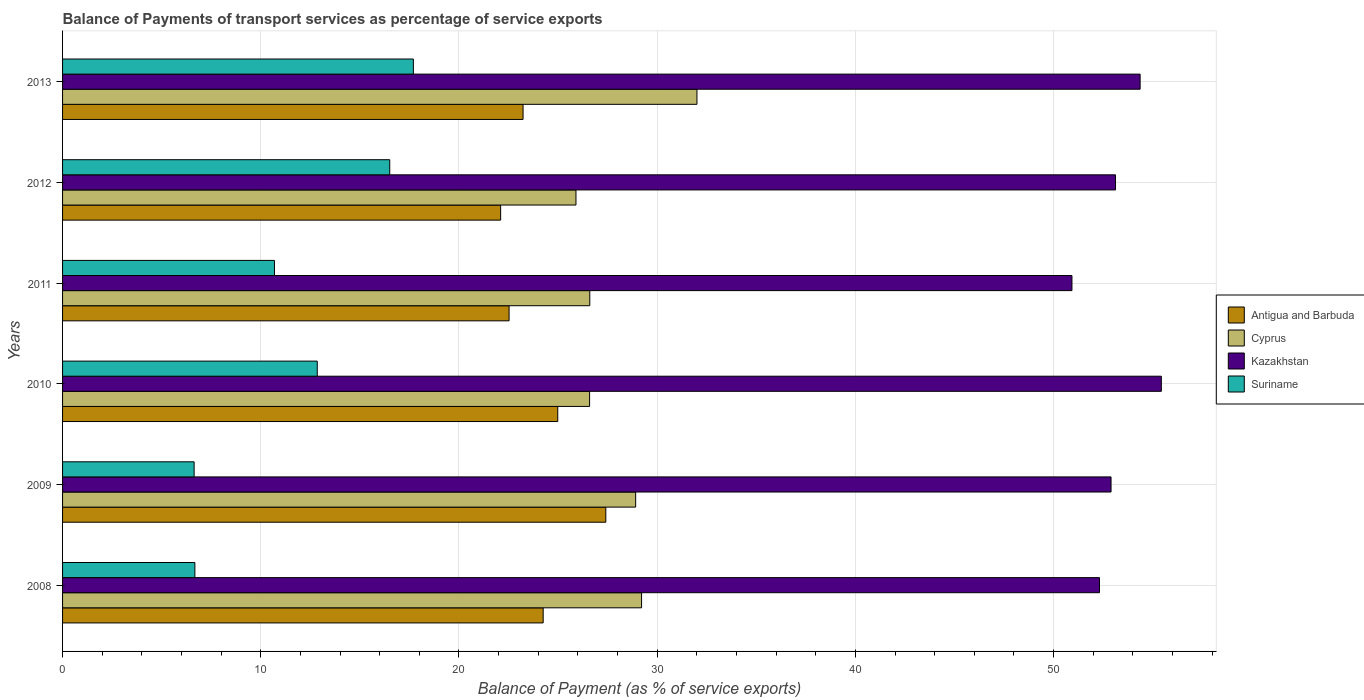How many groups of bars are there?
Your answer should be very brief. 6. Are the number of bars per tick equal to the number of legend labels?
Offer a very short reply. Yes. What is the label of the 1st group of bars from the top?
Provide a succinct answer. 2013. What is the balance of payments of transport services in Antigua and Barbuda in 2009?
Keep it short and to the point. 27.41. Across all years, what is the maximum balance of payments of transport services in Cyprus?
Give a very brief answer. 32.01. Across all years, what is the minimum balance of payments of transport services in Cyprus?
Keep it short and to the point. 25.9. In which year was the balance of payments of transport services in Kazakhstan minimum?
Ensure brevity in your answer.  2011. What is the total balance of payments of transport services in Kazakhstan in the graph?
Your answer should be compact. 319.06. What is the difference between the balance of payments of transport services in Cyprus in 2008 and that in 2010?
Provide a short and direct response. 2.62. What is the difference between the balance of payments of transport services in Suriname in 2010 and the balance of payments of transport services in Cyprus in 2013?
Offer a terse response. -19.16. What is the average balance of payments of transport services in Suriname per year?
Offer a very short reply. 11.84. In the year 2012, what is the difference between the balance of payments of transport services in Antigua and Barbuda and balance of payments of transport services in Suriname?
Your answer should be compact. 5.6. What is the ratio of the balance of payments of transport services in Antigua and Barbuda in 2010 to that in 2013?
Your response must be concise. 1.08. Is the balance of payments of transport services in Suriname in 2010 less than that in 2011?
Ensure brevity in your answer.  No. Is the difference between the balance of payments of transport services in Antigua and Barbuda in 2008 and 2011 greater than the difference between the balance of payments of transport services in Suriname in 2008 and 2011?
Provide a succinct answer. Yes. What is the difference between the highest and the second highest balance of payments of transport services in Antigua and Barbuda?
Provide a succinct answer. 2.43. What is the difference between the highest and the lowest balance of payments of transport services in Antigua and Barbuda?
Provide a short and direct response. 5.31. In how many years, is the balance of payments of transport services in Suriname greater than the average balance of payments of transport services in Suriname taken over all years?
Ensure brevity in your answer.  3. Is the sum of the balance of payments of transport services in Cyprus in 2008 and 2009 greater than the maximum balance of payments of transport services in Suriname across all years?
Provide a succinct answer. Yes. Is it the case that in every year, the sum of the balance of payments of transport services in Suriname and balance of payments of transport services in Kazakhstan is greater than the sum of balance of payments of transport services in Antigua and Barbuda and balance of payments of transport services in Cyprus?
Ensure brevity in your answer.  Yes. What does the 2nd bar from the top in 2011 represents?
Provide a short and direct response. Kazakhstan. What does the 2nd bar from the bottom in 2009 represents?
Your response must be concise. Cyprus. How many bars are there?
Provide a succinct answer. 24. Are all the bars in the graph horizontal?
Provide a short and direct response. Yes. How many years are there in the graph?
Your answer should be compact. 6. What is the difference between two consecutive major ticks on the X-axis?
Provide a succinct answer. 10. Are the values on the major ticks of X-axis written in scientific E-notation?
Your answer should be very brief. No. How many legend labels are there?
Provide a short and direct response. 4. What is the title of the graph?
Provide a short and direct response. Balance of Payments of transport services as percentage of service exports. Does "Congo (Republic)" appear as one of the legend labels in the graph?
Offer a terse response. No. What is the label or title of the X-axis?
Give a very brief answer. Balance of Payment (as % of service exports). What is the Balance of Payment (as % of service exports) of Antigua and Barbuda in 2008?
Your answer should be compact. 24.25. What is the Balance of Payment (as % of service exports) in Cyprus in 2008?
Provide a succinct answer. 29.21. What is the Balance of Payment (as % of service exports) in Kazakhstan in 2008?
Your answer should be compact. 52.32. What is the Balance of Payment (as % of service exports) of Suriname in 2008?
Provide a short and direct response. 6.67. What is the Balance of Payment (as % of service exports) in Antigua and Barbuda in 2009?
Your answer should be very brief. 27.41. What is the Balance of Payment (as % of service exports) of Cyprus in 2009?
Give a very brief answer. 28.91. What is the Balance of Payment (as % of service exports) in Kazakhstan in 2009?
Offer a terse response. 52.9. What is the Balance of Payment (as % of service exports) in Suriname in 2009?
Ensure brevity in your answer.  6.64. What is the Balance of Payment (as % of service exports) of Antigua and Barbuda in 2010?
Offer a terse response. 24.98. What is the Balance of Payment (as % of service exports) of Cyprus in 2010?
Offer a very short reply. 26.59. What is the Balance of Payment (as % of service exports) of Kazakhstan in 2010?
Offer a terse response. 55.44. What is the Balance of Payment (as % of service exports) of Suriname in 2010?
Your answer should be very brief. 12.85. What is the Balance of Payment (as % of service exports) of Antigua and Barbuda in 2011?
Your answer should be compact. 22.53. What is the Balance of Payment (as % of service exports) of Cyprus in 2011?
Offer a very short reply. 26.6. What is the Balance of Payment (as % of service exports) in Kazakhstan in 2011?
Give a very brief answer. 50.93. What is the Balance of Payment (as % of service exports) of Suriname in 2011?
Provide a short and direct response. 10.69. What is the Balance of Payment (as % of service exports) of Antigua and Barbuda in 2012?
Your answer should be very brief. 22.1. What is the Balance of Payment (as % of service exports) of Cyprus in 2012?
Your answer should be compact. 25.9. What is the Balance of Payment (as % of service exports) of Kazakhstan in 2012?
Keep it short and to the point. 53.12. What is the Balance of Payment (as % of service exports) of Suriname in 2012?
Keep it short and to the point. 16.51. What is the Balance of Payment (as % of service exports) in Antigua and Barbuda in 2013?
Make the answer very short. 23.23. What is the Balance of Payment (as % of service exports) in Cyprus in 2013?
Make the answer very short. 32.01. What is the Balance of Payment (as % of service exports) in Kazakhstan in 2013?
Your answer should be very brief. 54.36. What is the Balance of Payment (as % of service exports) of Suriname in 2013?
Keep it short and to the point. 17.7. Across all years, what is the maximum Balance of Payment (as % of service exports) of Antigua and Barbuda?
Your response must be concise. 27.41. Across all years, what is the maximum Balance of Payment (as % of service exports) in Cyprus?
Give a very brief answer. 32.01. Across all years, what is the maximum Balance of Payment (as % of service exports) in Kazakhstan?
Keep it short and to the point. 55.44. Across all years, what is the maximum Balance of Payment (as % of service exports) of Suriname?
Offer a very short reply. 17.7. Across all years, what is the minimum Balance of Payment (as % of service exports) of Antigua and Barbuda?
Provide a succinct answer. 22.1. Across all years, what is the minimum Balance of Payment (as % of service exports) of Cyprus?
Keep it short and to the point. 25.9. Across all years, what is the minimum Balance of Payment (as % of service exports) of Kazakhstan?
Offer a terse response. 50.93. Across all years, what is the minimum Balance of Payment (as % of service exports) of Suriname?
Provide a succinct answer. 6.64. What is the total Balance of Payment (as % of service exports) in Antigua and Barbuda in the graph?
Make the answer very short. 144.5. What is the total Balance of Payment (as % of service exports) of Cyprus in the graph?
Give a very brief answer. 169.22. What is the total Balance of Payment (as % of service exports) of Kazakhstan in the graph?
Make the answer very short. 319.06. What is the total Balance of Payment (as % of service exports) in Suriname in the graph?
Keep it short and to the point. 71.06. What is the difference between the Balance of Payment (as % of service exports) of Antigua and Barbuda in 2008 and that in 2009?
Your answer should be very brief. -3.16. What is the difference between the Balance of Payment (as % of service exports) of Cyprus in 2008 and that in 2009?
Keep it short and to the point. 0.3. What is the difference between the Balance of Payment (as % of service exports) in Kazakhstan in 2008 and that in 2009?
Provide a succinct answer. -0.58. What is the difference between the Balance of Payment (as % of service exports) of Suriname in 2008 and that in 2009?
Your answer should be very brief. 0.04. What is the difference between the Balance of Payment (as % of service exports) in Antigua and Barbuda in 2008 and that in 2010?
Give a very brief answer. -0.74. What is the difference between the Balance of Payment (as % of service exports) in Cyprus in 2008 and that in 2010?
Ensure brevity in your answer.  2.62. What is the difference between the Balance of Payment (as % of service exports) in Kazakhstan in 2008 and that in 2010?
Give a very brief answer. -3.12. What is the difference between the Balance of Payment (as % of service exports) in Suriname in 2008 and that in 2010?
Provide a short and direct response. -6.18. What is the difference between the Balance of Payment (as % of service exports) in Antigua and Barbuda in 2008 and that in 2011?
Give a very brief answer. 1.72. What is the difference between the Balance of Payment (as % of service exports) of Cyprus in 2008 and that in 2011?
Your response must be concise. 2.61. What is the difference between the Balance of Payment (as % of service exports) of Kazakhstan in 2008 and that in 2011?
Make the answer very short. 1.39. What is the difference between the Balance of Payment (as % of service exports) in Suriname in 2008 and that in 2011?
Your answer should be very brief. -4.02. What is the difference between the Balance of Payment (as % of service exports) in Antigua and Barbuda in 2008 and that in 2012?
Your answer should be very brief. 2.15. What is the difference between the Balance of Payment (as % of service exports) of Cyprus in 2008 and that in 2012?
Offer a very short reply. 3.31. What is the difference between the Balance of Payment (as % of service exports) of Kazakhstan in 2008 and that in 2012?
Provide a succinct answer. -0.81. What is the difference between the Balance of Payment (as % of service exports) in Suriname in 2008 and that in 2012?
Your response must be concise. -9.83. What is the difference between the Balance of Payment (as % of service exports) of Antigua and Barbuda in 2008 and that in 2013?
Keep it short and to the point. 1.01. What is the difference between the Balance of Payment (as % of service exports) of Cyprus in 2008 and that in 2013?
Your response must be concise. -2.79. What is the difference between the Balance of Payment (as % of service exports) of Kazakhstan in 2008 and that in 2013?
Keep it short and to the point. -2.05. What is the difference between the Balance of Payment (as % of service exports) in Suriname in 2008 and that in 2013?
Keep it short and to the point. -11.02. What is the difference between the Balance of Payment (as % of service exports) of Antigua and Barbuda in 2009 and that in 2010?
Your answer should be very brief. 2.43. What is the difference between the Balance of Payment (as % of service exports) of Cyprus in 2009 and that in 2010?
Your answer should be compact. 2.32. What is the difference between the Balance of Payment (as % of service exports) of Kazakhstan in 2009 and that in 2010?
Make the answer very short. -2.54. What is the difference between the Balance of Payment (as % of service exports) of Suriname in 2009 and that in 2010?
Provide a short and direct response. -6.21. What is the difference between the Balance of Payment (as % of service exports) of Antigua and Barbuda in 2009 and that in 2011?
Provide a succinct answer. 4.88. What is the difference between the Balance of Payment (as % of service exports) of Cyprus in 2009 and that in 2011?
Offer a terse response. 2.31. What is the difference between the Balance of Payment (as % of service exports) of Kazakhstan in 2009 and that in 2011?
Your response must be concise. 1.97. What is the difference between the Balance of Payment (as % of service exports) in Suriname in 2009 and that in 2011?
Your response must be concise. -4.05. What is the difference between the Balance of Payment (as % of service exports) of Antigua and Barbuda in 2009 and that in 2012?
Offer a terse response. 5.31. What is the difference between the Balance of Payment (as % of service exports) of Cyprus in 2009 and that in 2012?
Offer a very short reply. 3.01. What is the difference between the Balance of Payment (as % of service exports) in Kazakhstan in 2009 and that in 2012?
Provide a succinct answer. -0.23. What is the difference between the Balance of Payment (as % of service exports) of Suriname in 2009 and that in 2012?
Ensure brevity in your answer.  -9.87. What is the difference between the Balance of Payment (as % of service exports) in Antigua and Barbuda in 2009 and that in 2013?
Your answer should be very brief. 4.17. What is the difference between the Balance of Payment (as % of service exports) in Cyprus in 2009 and that in 2013?
Provide a succinct answer. -3.09. What is the difference between the Balance of Payment (as % of service exports) of Kazakhstan in 2009 and that in 2013?
Offer a very short reply. -1.47. What is the difference between the Balance of Payment (as % of service exports) in Suriname in 2009 and that in 2013?
Ensure brevity in your answer.  -11.06. What is the difference between the Balance of Payment (as % of service exports) of Antigua and Barbuda in 2010 and that in 2011?
Your answer should be compact. 2.46. What is the difference between the Balance of Payment (as % of service exports) in Cyprus in 2010 and that in 2011?
Your response must be concise. -0.01. What is the difference between the Balance of Payment (as % of service exports) of Kazakhstan in 2010 and that in 2011?
Provide a short and direct response. 4.51. What is the difference between the Balance of Payment (as % of service exports) in Suriname in 2010 and that in 2011?
Offer a very short reply. 2.16. What is the difference between the Balance of Payment (as % of service exports) in Antigua and Barbuda in 2010 and that in 2012?
Your answer should be compact. 2.88. What is the difference between the Balance of Payment (as % of service exports) of Cyprus in 2010 and that in 2012?
Your response must be concise. 0.69. What is the difference between the Balance of Payment (as % of service exports) of Kazakhstan in 2010 and that in 2012?
Provide a succinct answer. 2.31. What is the difference between the Balance of Payment (as % of service exports) in Suriname in 2010 and that in 2012?
Give a very brief answer. -3.66. What is the difference between the Balance of Payment (as % of service exports) of Antigua and Barbuda in 2010 and that in 2013?
Your answer should be very brief. 1.75. What is the difference between the Balance of Payment (as % of service exports) in Cyprus in 2010 and that in 2013?
Your answer should be compact. -5.42. What is the difference between the Balance of Payment (as % of service exports) of Kazakhstan in 2010 and that in 2013?
Your response must be concise. 1.07. What is the difference between the Balance of Payment (as % of service exports) in Suriname in 2010 and that in 2013?
Your response must be concise. -4.85. What is the difference between the Balance of Payment (as % of service exports) of Antigua and Barbuda in 2011 and that in 2012?
Make the answer very short. 0.43. What is the difference between the Balance of Payment (as % of service exports) of Cyprus in 2011 and that in 2012?
Give a very brief answer. 0.7. What is the difference between the Balance of Payment (as % of service exports) of Kazakhstan in 2011 and that in 2012?
Ensure brevity in your answer.  -2.2. What is the difference between the Balance of Payment (as % of service exports) in Suriname in 2011 and that in 2012?
Keep it short and to the point. -5.82. What is the difference between the Balance of Payment (as % of service exports) of Antigua and Barbuda in 2011 and that in 2013?
Provide a short and direct response. -0.71. What is the difference between the Balance of Payment (as % of service exports) of Cyprus in 2011 and that in 2013?
Provide a succinct answer. -5.41. What is the difference between the Balance of Payment (as % of service exports) of Kazakhstan in 2011 and that in 2013?
Your answer should be compact. -3.44. What is the difference between the Balance of Payment (as % of service exports) of Suriname in 2011 and that in 2013?
Provide a succinct answer. -7.01. What is the difference between the Balance of Payment (as % of service exports) of Antigua and Barbuda in 2012 and that in 2013?
Make the answer very short. -1.13. What is the difference between the Balance of Payment (as % of service exports) in Cyprus in 2012 and that in 2013?
Provide a short and direct response. -6.1. What is the difference between the Balance of Payment (as % of service exports) in Kazakhstan in 2012 and that in 2013?
Your response must be concise. -1.24. What is the difference between the Balance of Payment (as % of service exports) in Suriname in 2012 and that in 2013?
Offer a terse response. -1.19. What is the difference between the Balance of Payment (as % of service exports) of Antigua and Barbuda in 2008 and the Balance of Payment (as % of service exports) of Cyprus in 2009?
Your answer should be compact. -4.67. What is the difference between the Balance of Payment (as % of service exports) in Antigua and Barbuda in 2008 and the Balance of Payment (as % of service exports) in Kazakhstan in 2009?
Your answer should be compact. -28.65. What is the difference between the Balance of Payment (as % of service exports) of Antigua and Barbuda in 2008 and the Balance of Payment (as % of service exports) of Suriname in 2009?
Your response must be concise. 17.61. What is the difference between the Balance of Payment (as % of service exports) in Cyprus in 2008 and the Balance of Payment (as % of service exports) in Kazakhstan in 2009?
Offer a terse response. -23.69. What is the difference between the Balance of Payment (as % of service exports) of Cyprus in 2008 and the Balance of Payment (as % of service exports) of Suriname in 2009?
Your answer should be compact. 22.57. What is the difference between the Balance of Payment (as % of service exports) of Kazakhstan in 2008 and the Balance of Payment (as % of service exports) of Suriname in 2009?
Provide a succinct answer. 45.68. What is the difference between the Balance of Payment (as % of service exports) of Antigua and Barbuda in 2008 and the Balance of Payment (as % of service exports) of Cyprus in 2010?
Provide a short and direct response. -2.34. What is the difference between the Balance of Payment (as % of service exports) in Antigua and Barbuda in 2008 and the Balance of Payment (as % of service exports) in Kazakhstan in 2010?
Give a very brief answer. -31.19. What is the difference between the Balance of Payment (as % of service exports) of Antigua and Barbuda in 2008 and the Balance of Payment (as % of service exports) of Suriname in 2010?
Keep it short and to the point. 11.4. What is the difference between the Balance of Payment (as % of service exports) in Cyprus in 2008 and the Balance of Payment (as % of service exports) in Kazakhstan in 2010?
Provide a short and direct response. -26.22. What is the difference between the Balance of Payment (as % of service exports) of Cyprus in 2008 and the Balance of Payment (as % of service exports) of Suriname in 2010?
Ensure brevity in your answer.  16.36. What is the difference between the Balance of Payment (as % of service exports) of Kazakhstan in 2008 and the Balance of Payment (as % of service exports) of Suriname in 2010?
Give a very brief answer. 39.47. What is the difference between the Balance of Payment (as % of service exports) of Antigua and Barbuda in 2008 and the Balance of Payment (as % of service exports) of Cyprus in 2011?
Ensure brevity in your answer.  -2.35. What is the difference between the Balance of Payment (as % of service exports) in Antigua and Barbuda in 2008 and the Balance of Payment (as % of service exports) in Kazakhstan in 2011?
Your response must be concise. -26.68. What is the difference between the Balance of Payment (as % of service exports) in Antigua and Barbuda in 2008 and the Balance of Payment (as % of service exports) in Suriname in 2011?
Ensure brevity in your answer.  13.56. What is the difference between the Balance of Payment (as % of service exports) in Cyprus in 2008 and the Balance of Payment (as % of service exports) in Kazakhstan in 2011?
Give a very brief answer. -21.71. What is the difference between the Balance of Payment (as % of service exports) of Cyprus in 2008 and the Balance of Payment (as % of service exports) of Suriname in 2011?
Keep it short and to the point. 18.52. What is the difference between the Balance of Payment (as % of service exports) of Kazakhstan in 2008 and the Balance of Payment (as % of service exports) of Suriname in 2011?
Provide a succinct answer. 41.62. What is the difference between the Balance of Payment (as % of service exports) of Antigua and Barbuda in 2008 and the Balance of Payment (as % of service exports) of Cyprus in 2012?
Your answer should be very brief. -1.65. What is the difference between the Balance of Payment (as % of service exports) in Antigua and Barbuda in 2008 and the Balance of Payment (as % of service exports) in Kazakhstan in 2012?
Your response must be concise. -28.88. What is the difference between the Balance of Payment (as % of service exports) of Antigua and Barbuda in 2008 and the Balance of Payment (as % of service exports) of Suriname in 2012?
Make the answer very short. 7.74. What is the difference between the Balance of Payment (as % of service exports) of Cyprus in 2008 and the Balance of Payment (as % of service exports) of Kazakhstan in 2012?
Make the answer very short. -23.91. What is the difference between the Balance of Payment (as % of service exports) of Cyprus in 2008 and the Balance of Payment (as % of service exports) of Suriname in 2012?
Your answer should be compact. 12.71. What is the difference between the Balance of Payment (as % of service exports) in Kazakhstan in 2008 and the Balance of Payment (as % of service exports) in Suriname in 2012?
Offer a terse response. 35.81. What is the difference between the Balance of Payment (as % of service exports) in Antigua and Barbuda in 2008 and the Balance of Payment (as % of service exports) in Cyprus in 2013?
Offer a very short reply. -7.76. What is the difference between the Balance of Payment (as % of service exports) of Antigua and Barbuda in 2008 and the Balance of Payment (as % of service exports) of Kazakhstan in 2013?
Give a very brief answer. -30.12. What is the difference between the Balance of Payment (as % of service exports) of Antigua and Barbuda in 2008 and the Balance of Payment (as % of service exports) of Suriname in 2013?
Give a very brief answer. 6.55. What is the difference between the Balance of Payment (as % of service exports) of Cyprus in 2008 and the Balance of Payment (as % of service exports) of Kazakhstan in 2013?
Give a very brief answer. -25.15. What is the difference between the Balance of Payment (as % of service exports) of Cyprus in 2008 and the Balance of Payment (as % of service exports) of Suriname in 2013?
Offer a very short reply. 11.51. What is the difference between the Balance of Payment (as % of service exports) of Kazakhstan in 2008 and the Balance of Payment (as % of service exports) of Suriname in 2013?
Your response must be concise. 34.62. What is the difference between the Balance of Payment (as % of service exports) of Antigua and Barbuda in 2009 and the Balance of Payment (as % of service exports) of Cyprus in 2010?
Ensure brevity in your answer.  0.82. What is the difference between the Balance of Payment (as % of service exports) in Antigua and Barbuda in 2009 and the Balance of Payment (as % of service exports) in Kazakhstan in 2010?
Your answer should be very brief. -28.03. What is the difference between the Balance of Payment (as % of service exports) of Antigua and Barbuda in 2009 and the Balance of Payment (as % of service exports) of Suriname in 2010?
Your answer should be very brief. 14.56. What is the difference between the Balance of Payment (as % of service exports) in Cyprus in 2009 and the Balance of Payment (as % of service exports) in Kazakhstan in 2010?
Offer a very short reply. -26.52. What is the difference between the Balance of Payment (as % of service exports) of Cyprus in 2009 and the Balance of Payment (as % of service exports) of Suriname in 2010?
Provide a succinct answer. 16.06. What is the difference between the Balance of Payment (as % of service exports) of Kazakhstan in 2009 and the Balance of Payment (as % of service exports) of Suriname in 2010?
Offer a terse response. 40.05. What is the difference between the Balance of Payment (as % of service exports) in Antigua and Barbuda in 2009 and the Balance of Payment (as % of service exports) in Cyprus in 2011?
Your answer should be very brief. 0.81. What is the difference between the Balance of Payment (as % of service exports) in Antigua and Barbuda in 2009 and the Balance of Payment (as % of service exports) in Kazakhstan in 2011?
Offer a very short reply. -23.52. What is the difference between the Balance of Payment (as % of service exports) in Antigua and Barbuda in 2009 and the Balance of Payment (as % of service exports) in Suriname in 2011?
Keep it short and to the point. 16.72. What is the difference between the Balance of Payment (as % of service exports) of Cyprus in 2009 and the Balance of Payment (as % of service exports) of Kazakhstan in 2011?
Keep it short and to the point. -22.01. What is the difference between the Balance of Payment (as % of service exports) in Cyprus in 2009 and the Balance of Payment (as % of service exports) in Suriname in 2011?
Offer a very short reply. 18.22. What is the difference between the Balance of Payment (as % of service exports) of Kazakhstan in 2009 and the Balance of Payment (as % of service exports) of Suriname in 2011?
Your answer should be very brief. 42.21. What is the difference between the Balance of Payment (as % of service exports) in Antigua and Barbuda in 2009 and the Balance of Payment (as % of service exports) in Cyprus in 2012?
Offer a terse response. 1.51. What is the difference between the Balance of Payment (as % of service exports) in Antigua and Barbuda in 2009 and the Balance of Payment (as % of service exports) in Kazakhstan in 2012?
Give a very brief answer. -25.72. What is the difference between the Balance of Payment (as % of service exports) in Antigua and Barbuda in 2009 and the Balance of Payment (as % of service exports) in Suriname in 2012?
Provide a succinct answer. 10.9. What is the difference between the Balance of Payment (as % of service exports) of Cyprus in 2009 and the Balance of Payment (as % of service exports) of Kazakhstan in 2012?
Make the answer very short. -24.21. What is the difference between the Balance of Payment (as % of service exports) in Cyprus in 2009 and the Balance of Payment (as % of service exports) in Suriname in 2012?
Keep it short and to the point. 12.41. What is the difference between the Balance of Payment (as % of service exports) of Kazakhstan in 2009 and the Balance of Payment (as % of service exports) of Suriname in 2012?
Offer a terse response. 36.39. What is the difference between the Balance of Payment (as % of service exports) of Antigua and Barbuda in 2009 and the Balance of Payment (as % of service exports) of Cyprus in 2013?
Your answer should be compact. -4.6. What is the difference between the Balance of Payment (as % of service exports) in Antigua and Barbuda in 2009 and the Balance of Payment (as % of service exports) in Kazakhstan in 2013?
Ensure brevity in your answer.  -26.96. What is the difference between the Balance of Payment (as % of service exports) in Antigua and Barbuda in 2009 and the Balance of Payment (as % of service exports) in Suriname in 2013?
Your answer should be very brief. 9.71. What is the difference between the Balance of Payment (as % of service exports) of Cyprus in 2009 and the Balance of Payment (as % of service exports) of Kazakhstan in 2013?
Your answer should be very brief. -25.45. What is the difference between the Balance of Payment (as % of service exports) in Cyprus in 2009 and the Balance of Payment (as % of service exports) in Suriname in 2013?
Offer a very short reply. 11.21. What is the difference between the Balance of Payment (as % of service exports) of Kazakhstan in 2009 and the Balance of Payment (as % of service exports) of Suriname in 2013?
Your response must be concise. 35.2. What is the difference between the Balance of Payment (as % of service exports) in Antigua and Barbuda in 2010 and the Balance of Payment (as % of service exports) in Cyprus in 2011?
Ensure brevity in your answer.  -1.62. What is the difference between the Balance of Payment (as % of service exports) in Antigua and Barbuda in 2010 and the Balance of Payment (as % of service exports) in Kazakhstan in 2011?
Ensure brevity in your answer.  -25.94. What is the difference between the Balance of Payment (as % of service exports) of Antigua and Barbuda in 2010 and the Balance of Payment (as % of service exports) of Suriname in 2011?
Keep it short and to the point. 14.29. What is the difference between the Balance of Payment (as % of service exports) of Cyprus in 2010 and the Balance of Payment (as % of service exports) of Kazakhstan in 2011?
Your answer should be very brief. -24.34. What is the difference between the Balance of Payment (as % of service exports) in Cyprus in 2010 and the Balance of Payment (as % of service exports) in Suriname in 2011?
Offer a very short reply. 15.9. What is the difference between the Balance of Payment (as % of service exports) in Kazakhstan in 2010 and the Balance of Payment (as % of service exports) in Suriname in 2011?
Give a very brief answer. 44.74. What is the difference between the Balance of Payment (as % of service exports) of Antigua and Barbuda in 2010 and the Balance of Payment (as % of service exports) of Cyprus in 2012?
Provide a short and direct response. -0.92. What is the difference between the Balance of Payment (as % of service exports) in Antigua and Barbuda in 2010 and the Balance of Payment (as % of service exports) in Kazakhstan in 2012?
Make the answer very short. -28.14. What is the difference between the Balance of Payment (as % of service exports) of Antigua and Barbuda in 2010 and the Balance of Payment (as % of service exports) of Suriname in 2012?
Offer a terse response. 8.48. What is the difference between the Balance of Payment (as % of service exports) in Cyprus in 2010 and the Balance of Payment (as % of service exports) in Kazakhstan in 2012?
Provide a succinct answer. -26.53. What is the difference between the Balance of Payment (as % of service exports) in Cyprus in 2010 and the Balance of Payment (as % of service exports) in Suriname in 2012?
Your response must be concise. 10.08. What is the difference between the Balance of Payment (as % of service exports) in Kazakhstan in 2010 and the Balance of Payment (as % of service exports) in Suriname in 2012?
Make the answer very short. 38.93. What is the difference between the Balance of Payment (as % of service exports) of Antigua and Barbuda in 2010 and the Balance of Payment (as % of service exports) of Cyprus in 2013?
Give a very brief answer. -7.02. What is the difference between the Balance of Payment (as % of service exports) of Antigua and Barbuda in 2010 and the Balance of Payment (as % of service exports) of Kazakhstan in 2013?
Give a very brief answer. -29.38. What is the difference between the Balance of Payment (as % of service exports) in Antigua and Barbuda in 2010 and the Balance of Payment (as % of service exports) in Suriname in 2013?
Your response must be concise. 7.28. What is the difference between the Balance of Payment (as % of service exports) in Cyprus in 2010 and the Balance of Payment (as % of service exports) in Kazakhstan in 2013?
Provide a short and direct response. -27.78. What is the difference between the Balance of Payment (as % of service exports) in Cyprus in 2010 and the Balance of Payment (as % of service exports) in Suriname in 2013?
Offer a very short reply. 8.89. What is the difference between the Balance of Payment (as % of service exports) of Kazakhstan in 2010 and the Balance of Payment (as % of service exports) of Suriname in 2013?
Give a very brief answer. 37.74. What is the difference between the Balance of Payment (as % of service exports) of Antigua and Barbuda in 2011 and the Balance of Payment (as % of service exports) of Cyprus in 2012?
Provide a short and direct response. -3.37. What is the difference between the Balance of Payment (as % of service exports) in Antigua and Barbuda in 2011 and the Balance of Payment (as % of service exports) in Kazakhstan in 2012?
Provide a succinct answer. -30.6. What is the difference between the Balance of Payment (as % of service exports) of Antigua and Barbuda in 2011 and the Balance of Payment (as % of service exports) of Suriname in 2012?
Offer a terse response. 6.02. What is the difference between the Balance of Payment (as % of service exports) of Cyprus in 2011 and the Balance of Payment (as % of service exports) of Kazakhstan in 2012?
Ensure brevity in your answer.  -26.52. What is the difference between the Balance of Payment (as % of service exports) of Cyprus in 2011 and the Balance of Payment (as % of service exports) of Suriname in 2012?
Your response must be concise. 10.09. What is the difference between the Balance of Payment (as % of service exports) of Kazakhstan in 2011 and the Balance of Payment (as % of service exports) of Suriname in 2012?
Provide a short and direct response. 34.42. What is the difference between the Balance of Payment (as % of service exports) in Antigua and Barbuda in 2011 and the Balance of Payment (as % of service exports) in Cyprus in 2013?
Your response must be concise. -9.48. What is the difference between the Balance of Payment (as % of service exports) of Antigua and Barbuda in 2011 and the Balance of Payment (as % of service exports) of Kazakhstan in 2013?
Give a very brief answer. -31.84. What is the difference between the Balance of Payment (as % of service exports) in Antigua and Barbuda in 2011 and the Balance of Payment (as % of service exports) in Suriname in 2013?
Offer a terse response. 4.83. What is the difference between the Balance of Payment (as % of service exports) in Cyprus in 2011 and the Balance of Payment (as % of service exports) in Kazakhstan in 2013?
Offer a very short reply. -27.77. What is the difference between the Balance of Payment (as % of service exports) in Cyprus in 2011 and the Balance of Payment (as % of service exports) in Suriname in 2013?
Your response must be concise. 8.9. What is the difference between the Balance of Payment (as % of service exports) of Kazakhstan in 2011 and the Balance of Payment (as % of service exports) of Suriname in 2013?
Provide a short and direct response. 33.23. What is the difference between the Balance of Payment (as % of service exports) in Antigua and Barbuda in 2012 and the Balance of Payment (as % of service exports) in Cyprus in 2013?
Give a very brief answer. -9.9. What is the difference between the Balance of Payment (as % of service exports) in Antigua and Barbuda in 2012 and the Balance of Payment (as % of service exports) in Kazakhstan in 2013?
Provide a succinct answer. -32.26. What is the difference between the Balance of Payment (as % of service exports) in Antigua and Barbuda in 2012 and the Balance of Payment (as % of service exports) in Suriname in 2013?
Give a very brief answer. 4.4. What is the difference between the Balance of Payment (as % of service exports) of Cyprus in 2012 and the Balance of Payment (as % of service exports) of Kazakhstan in 2013?
Your response must be concise. -28.46. What is the difference between the Balance of Payment (as % of service exports) in Cyprus in 2012 and the Balance of Payment (as % of service exports) in Suriname in 2013?
Your answer should be very brief. 8.2. What is the difference between the Balance of Payment (as % of service exports) in Kazakhstan in 2012 and the Balance of Payment (as % of service exports) in Suriname in 2013?
Your response must be concise. 35.43. What is the average Balance of Payment (as % of service exports) of Antigua and Barbuda per year?
Provide a short and direct response. 24.08. What is the average Balance of Payment (as % of service exports) of Cyprus per year?
Provide a short and direct response. 28.2. What is the average Balance of Payment (as % of service exports) of Kazakhstan per year?
Provide a short and direct response. 53.18. What is the average Balance of Payment (as % of service exports) of Suriname per year?
Offer a very short reply. 11.84. In the year 2008, what is the difference between the Balance of Payment (as % of service exports) of Antigua and Barbuda and Balance of Payment (as % of service exports) of Cyprus?
Keep it short and to the point. -4.97. In the year 2008, what is the difference between the Balance of Payment (as % of service exports) of Antigua and Barbuda and Balance of Payment (as % of service exports) of Kazakhstan?
Provide a succinct answer. -28.07. In the year 2008, what is the difference between the Balance of Payment (as % of service exports) of Antigua and Barbuda and Balance of Payment (as % of service exports) of Suriname?
Ensure brevity in your answer.  17.57. In the year 2008, what is the difference between the Balance of Payment (as % of service exports) of Cyprus and Balance of Payment (as % of service exports) of Kazakhstan?
Your answer should be very brief. -23.1. In the year 2008, what is the difference between the Balance of Payment (as % of service exports) of Cyprus and Balance of Payment (as % of service exports) of Suriname?
Offer a terse response. 22.54. In the year 2008, what is the difference between the Balance of Payment (as % of service exports) of Kazakhstan and Balance of Payment (as % of service exports) of Suriname?
Give a very brief answer. 45.64. In the year 2009, what is the difference between the Balance of Payment (as % of service exports) of Antigua and Barbuda and Balance of Payment (as % of service exports) of Cyprus?
Give a very brief answer. -1.51. In the year 2009, what is the difference between the Balance of Payment (as % of service exports) of Antigua and Barbuda and Balance of Payment (as % of service exports) of Kazakhstan?
Offer a terse response. -25.49. In the year 2009, what is the difference between the Balance of Payment (as % of service exports) in Antigua and Barbuda and Balance of Payment (as % of service exports) in Suriname?
Offer a terse response. 20.77. In the year 2009, what is the difference between the Balance of Payment (as % of service exports) in Cyprus and Balance of Payment (as % of service exports) in Kazakhstan?
Your response must be concise. -23.98. In the year 2009, what is the difference between the Balance of Payment (as % of service exports) in Cyprus and Balance of Payment (as % of service exports) in Suriname?
Give a very brief answer. 22.28. In the year 2009, what is the difference between the Balance of Payment (as % of service exports) of Kazakhstan and Balance of Payment (as % of service exports) of Suriname?
Provide a succinct answer. 46.26. In the year 2010, what is the difference between the Balance of Payment (as % of service exports) in Antigua and Barbuda and Balance of Payment (as % of service exports) in Cyprus?
Give a very brief answer. -1.61. In the year 2010, what is the difference between the Balance of Payment (as % of service exports) of Antigua and Barbuda and Balance of Payment (as % of service exports) of Kazakhstan?
Make the answer very short. -30.45. In the year 2010, what is the difference between the Balance of Payment (as % of service exports) in Antigua and Barbuda and Balance of Payment (as % of service exports) in Suriname?
Your response must be concise. 12.13. In the year 2010, what is the difference between the Balance of Payment (as % of service exports) in Cyprus and Balance of Payment (as % of service exports) in Kazakhstan?
Offer a terse response. -28.85. In the year 2010, what is the difference between the Balance of Payment (as % of service exports) in Cyprus and Balance of Payment (as % of service exports) in Suriname?
Make the answer very short. 13.74. In the year 2010, what is the difference between the Balance of Payment (as % of service exports) of Kazakhstan and Balance of Payment (as % of service exports) of Suriname?
Offer a terse response. 42.59. In the year 2011, what is the difference between the Balance of Payment (as % of service exports) of Antigua and Barbuda and Balance of Payment (as % of service exports) of Cyprus?
Offer a terse response. -4.07. In the year 2011, what is the difference between the Balance of Payment (as % of service exports) in Antigua and Barbuda and Balance of Payment (as % of service exports) in Kazakhstan?
Keep it short and to the point. -28.4. In the year 2011, what is the difference between the Balance of Payment (as % of service exports) in Antigua and Barbuda and Balance of Payment (as % of service exports) in Suriname?
Provide a succinct answer. 11.84. In the year 2011, what is the difference between the Balance of Payment (as % of service exports) of Cyprus and Balance of Payment (as % of service exports) of Kazakhstan?
Your answer should be very brief. -24.33. In the year 2011, what is the difference between the Balance of Payment (as % of service exports) of Cyprus and Balance of Payment (as % of service exports) of Suriname?
Make the answer very short. 15.91. In the year 2011, what is the difference between the Balance of Payment (as % of service exports) of Kazakhstan and Balance of Payment (as % of service exports) of Suriname?
Provide a succinct answer. 40.23. In the year 2012, what is the difference between the Balance of Payment (as % of service exports) in Antigua and Barbuda and Balance of Payment (as % of service exports) in Kazakhstan?
Your answer should be compact. -31.02. In the year 2012, what is the difference between the Balance of Payment (as % of service exports) of Antigua and Barbuda and Balance of Payment (as % of service exports) of Suriname?
Ensure brevity in your answer.  5.6. In the year 2012, what is the difference between the Balance of Payment (as % of service exports) in Cyprus and Balance of Payment (as % of service exports) in Kazakhstan?
Ensure brevity in your answer.  -27.22. In the year 2012, what is the difference between the Balance of Payment (as % of service exports) of Cyprus and Balance of Payment (as % of service exports) of Suriname?
Provide a succinct answer. 9.4. In the year 2012, what is the difference between the Balance of Payment (as % of service exports) in Kazakhstan and Balance of Payment (as % of service exports) in Suriname?
Your answer should be compact. 36.62. In the year 2013, what is the difference between the Balance of Payment (as % of service exports) in Antigua and Barbuda and Balance of Payment (as % of service exports) in Cyprus?
Your answer should be compact. -8.77. In the year 2013, what is the difference between the Balance of Payment (as % of service exports) of Antigua and Barbuda and Balance of Payment (as % of service exports) of Kazakhstan?
Your answer should be very brief. -31.13. In the year 2013, what is the difference between the Balance of Payment (as % of service exports) in Antigua and Barbuda and Balance of Payment (as % of service exports) in Suriname?
Ensure brevity in your answer.  5.53. In the year 2013, what is the difference between the Balance of Payment (as % of service exports) in Cyprus and Balance of Payment (as % of service exports) in Kazakhstan?
Provide a succinct answer. -22.36. In the year 2013, what is the difference between the Balance of Payment (as % of service exports) in Cyprus and Balance of Payment (as % of service exports) in Suriname?
Ensure brevity in your answer.  14.31. In the year 2013, what is the difference between the Balance of Payment (as % of service exports) of Kazakhstan and Balance of Payment (as % of service exports) of Suriname?
Make the answer very short. 36.67. What is the ratio of the Balance of Payment (as % of service exports) in Antigua and Barbuda in 2008 to that in 2009?
Provide a succinct answer. 0.88. What is the ratio of the Balance of Payment (as % of service exports) of Cyprus in 2008 to that in 2009?
Offer a terse response. 1.01. What is the ratio of the Balance of Payment (as % of service exports) of Suriname in 2008 to that in 2009?
Provide a succinct answer. 1.01. What is the ratio of the Balance of Payment (as % of service exports) in Antigua and Barbuda in 2008 to that in 2010?
Offer a terse response. 0.97. What is the ratio of the Balance of Payment (as % of service exports) in Cyprus in 2008 to that in 2010?
Your response must be concise. 1.1. What is the ratio of the Balance of Payment (as % of service exports) in Kazakhstan in 2008 to that in 2010?
Your answer should be very brief. 0.94. What is the ratio of the Balance of Payment (as % of service exports) in Suriname in 2008 to that in 2010?
Offer a very short reply. 0.52. What is the ratio of the Balance of Payment (as % of service exports) of Antigua and Barbuda in 2008 to that in 2011?
Offer a very short reply. 1.08. What is the ratio of the Balance of Payment (as % of service exports) of Cyprus in 2008 to that in 2011?
Your answer should be compact. 1.1. What is the ratio of the Balance of Payment (as % of service exports) in Kazakhstan in 2008 to that in 2011?
Provide a short and direct response. 1.03. What is the ratio of the Balance of Payment (as % of service exports) in Suriname in 2008 to that in 2011?
Offer a very short reply. 0.62. What is the ratio of the Balance of Payment (as % of service exports) of Antigua and Barbuda in 2008 to that in 2012?
Offer a terse response. 1.1. What is the ratio of the Balance of Payment (as % of service exports) in Cyprus in 2008 to that in 2012?
Give a very brief answer. 1.13. What is the ratio of the Balance of Payment (as % of service exports) in Suriname in 2008 to that in 2012?
Offer a terse response. 0.4. What is the ratio of the Balance of Payment (as % of service exports) in Antigua and Barbuda in 2008 to that in 2013?
Your answer should be very brief. 1.04. What is the ratio of the Balance of Payment (as % of service exports) of Cyprus in 2008 to that in 2013?
Offer a terse response. 0.91. What is the ratio of the Balance of Payment (as % of service exports) in Kazakhstan in 2008 to that in 2013?
Your response must be concise. 0.96. What is the ratio of the Balance of Payment (as % of service exports) in Suriname in 2008 to that in 2013?
Keep it short and to the point. 0.38. What is the ratio of the Balance of Payment (as % of service exports) in Antigua and Barbuda in 2009 to that in 2010?
Your answer should be compact. 1.1. What is the ratio of the Balance of Payment (as % of service exports) in Cyprus in 2009 to that in 2010?
Give a very brief answer. 1.09. What is the ratio of the Balance of Payment (as % of service exports) of Kazakhstan in 2009 to that in 2010?
Offer a terse response. 0.95. What is the ratio of the Balance of Payment (as % of service exports) of Suriname in 2009 to that in 2010?
Give a very brief answer. 0.52. What is the ratio of the Balance of Payment (as % of service exports) in Antigua and Barbuda in 2009 to that in 2011?
Your answer should be very brief. 1.22. What is the ratio of the Balance of Payment (as % of service exports) of Cyprus in 2009 to that in 2011?
Keep it short and to the point. 1.09. What is the ratio of the Balance of Payment (as % of service exports) in Kazakhstan in 2009 to that in 2011?
Ensure brevity in your answer.  1.04. What is the ratio of the Balance of Payment (as % of service exports) of Suriname in 2009 to that in 2011?
Offer a very short reply. 0.62. What is the ratio of the Balance of Payment (as % of service exports) of Antigua and Barbuda in 2009 to that in 2012?
Provide a succinct answer. 1.24. What is the ratio of the Balance of Payment (as % of service exports) of Cyprus in 2009 to that in 2012?
Your answer should be very brief. 1.12. What is the ratio of the Balance of Payment (as % of service exports) of Kazakhstan in 2009 to that in 2012?
Offer a terse response. 1. What is the ratio of the Balance of Payment (as % of service exports) in Suriname in 2009 to that in 2012?
Your answer should be very brief. 0.4. What is the ratio of the Balance of Payment (as % of service exports) of Antigua and Barbuda in 2009 to that in 2013?
Your response must be concise. 1.18. What is the ratio of the Balance of Payment (as % of service exports) of Cyprus in 2009 to that in 2013?
Ensure brevity in your answer.  0.9. What is the ratio of the Balance of Payment (as % of service exports) of Kazakhstan in 2009 to that in 2013?
Your answer should be very brief. 0.97. What is the ratio of the Balance of Payment (as % of service exports) of Suriname in 2009 to that in 2013?
Your response must be concise. 0.38. What is the ratio of the Balance of Payment (as % of service exports) of Antigua and Barbuda in 2010 to that in 2011?
Your answer should be compact. 1.11. What is the ratio of the Balance of Payment (as % of service exports) of Kazakhstan in 2010 to that in 2011?
Your answer should be very brief. 1.09. What is the ratio of the Balance of Payment (as % of service exports) of Suriname in 2010 to that in 2011?
Ensure brevity in your answer.  1.2. What is the ratio of the Balance of Payment (as % of service exports) of Antigua and Barbuda in 2010 to that in 2012?
Your answer should be compact. 1.13. What is the ratio of the Balance of Payment (as % of service exports) of Cyprus in 2010 to that in 2012?
Your answer should be compact. 1.03. What is the ratio of the Balance of Payment (as % of service exports) in Kazakhstan in 2010 to that in 2012?
Your answer should be very brief. 1.04. What is the ratio of the Balance of Payment (as % of service exports) in Suriname in 2010 to that in 2012?
Your answer should be very brief. 0.78. What is the ratio of the Balance of Payment (as % of service exports) of Antigua and Barbuda in 2010 to that in 2013?
Your response must be concise. 1.08. What is the ratio of the Balance of Payment (as % of service exports) in Cyprus in 2010 to that in 2013?
Your answer should be very brief. 0.83. What is the ratio of the Balance of Payment (as % of service exports) of Kazakhstan in 2010 to that in 2013?
Provide a short and direct response. 1.02. What is the ratio of the Balance of Payment (as % of service exports) in Suriname in 2010 to that in 2013?
Ensure brevity in your answer.  0.73. What is the ratio of the Balance of Payment (as % of service exports) of Antigua and Barbuda in 2011 to that in 2012?
Make the answer very short. 1.02. What is the ratio of the Balance of Payment (as % of service exports) of Cyprus in 2011 to that in 2012?
Your answer should be compact. 1.03. What is the ratio of the Balance of Payment (as % of service exports) in Kazakhstan in 2011 to that in 2012?
Keep it short and to the point. 0.96. What is the ratio of the Balance of Payment (as % of service exports) of Suriname in 2011 to that in 2012?
Your answer should be compact. 0.65. What is the ratio of the Balance of Payment (as % of service exports) of Antigua and Barbuda in 2011 to that in 2013?
Offer a terse response. 0.97. What is the ratio of the Balance of Payment (as % of service exports) in Cyprus in 2011 to that in 2013?
Your answer should be compact. 0.83. What is the ratio of the Balance of Payment (as % of service exports) of Kazakhstan in 2011 to that in 2013?
Provide a short and direct response. 0.94. What is the ratio of the Balance of Payment (as % of service exports) of Suriname in 2011 to that in 2013?
Make the answer very short. 0.6. What is the ratio of the Balance of Payment (as % of service exports) of Antigua and Barbuda in 2012 to that in 2013?
Give a very brief answer. 0.95. What is the ratio of the Balance of Payment (as % of service exports) in Cyprus in 2012 to that in 2013?
Your answer should be compact. 0.81. What is the ratio of the Balance of Payment (as % of service exports) in Kazakhstan in 2012 to that in 2013?
Give a very brief answer. 0.98. What is the ratio of the Balance of Payment (as % of service exports) in Suriname in 2012 to that in 2013?
Your answer should be compact. 0.93. What is the difference between the highest and the second highest Balance of Payment (as % of service exports) in Antigua and Barbuda?
Provide a succinct answer. 2.43. What is the difference between the highest and the second highest Balance of Payment (as % of service exports) in Cyprus?
Offer a terse response. 2.79. What is the difference between the highest and the second highest Balance of Payment (as % of service exports) of Kazakhstan?
Ensure brevity in your answer.  1.07. What is the difference between the highest and the second highest Balance of Payment (as % of service exports) in Suriname?
Your response must be concise. 1.19. What is the difference between the highest and the lowest Balance of Payment (as % of service exports) of Antigua and Barbuda?
Offer a very short reply. 5.31. What is the difference between the highest and the lowest Balance of Payment (as % of service exports) in Cyprus?
Provide a short and direct response. 6.1. What is the difference between the highest and the lowest Balance of Payment (as % of service exports) of Kazakhstan?
Provide a short and direct response. 4.51. What is the difference between the highest and the lowest Balance of Payment (as % of service exports) of Suriname?
Your answer should be very brief. 11.06. 